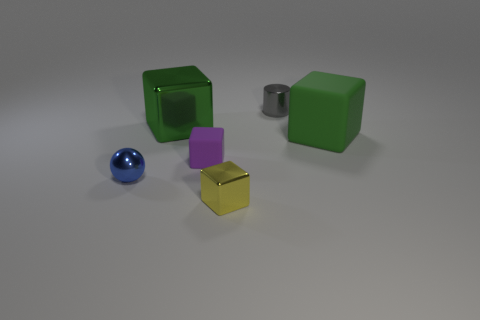If these objects represented elements in nature, what could each one symbolize? If we assign natural symbolism to these objects, the green cubes could represent elements of earth or nature, such as trees or foliage given their color and solid form. The purple cube could symbolize creativity or regality, often associated with the color purple. The reflective yellow might be the sun, with its bright and shiny demeanor, while the blue sphere could represent water due to its color and reflective quality. Lastly, the metallic cylinder might stand for human-made structures or technology, a juxtaposition to the more organic forms. 